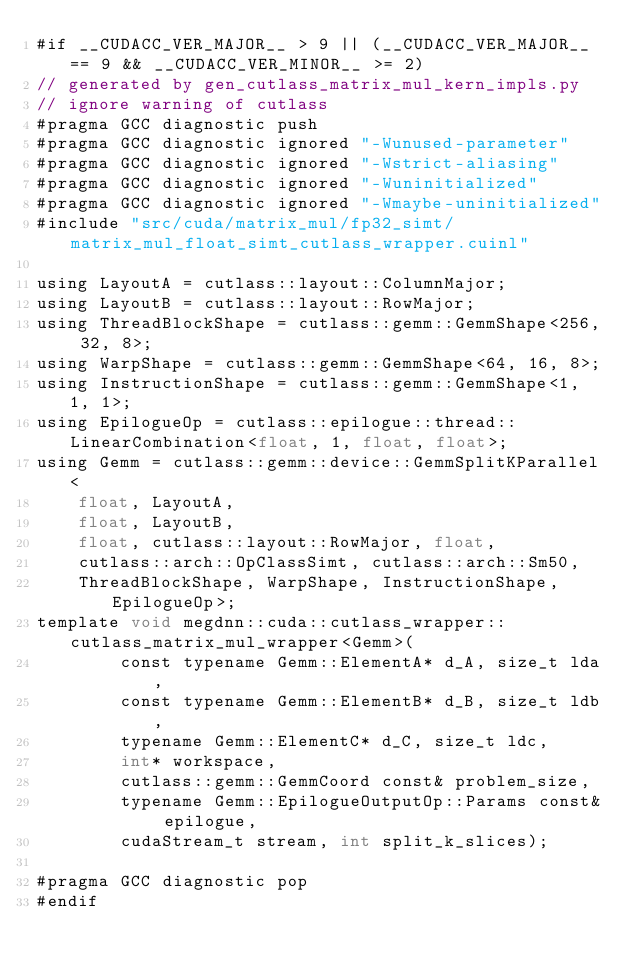<code> <loc_0><loc_0><loc_500><loc_500><_Cuda_>#if __CUDACC_VER_MAJOR__ > 9 || (__CUDACC_VER_MAJOR__ == 9 && __CUDACC_VER_MINOR__ >= 2)
// generated by gen_cutlass_matrix_mul_kern_impls.py
// ignore warning of cutlass
#pragma GCC diagnostic push
#pragma GCC diagnostic ignored "-Wunused-parameter"
#pragma GCC diagnostic ignored "-Wstrict-aliasing"
#pragma GCC diagnostic ignored "-Wuninitialized"
#pragma GCC diagnostic ignored "-Wmaybe-uninitialized"
#include "src/cuda/matrix_mul/fp32_simt/matrix_mul_float_simt_cutlass_wrapper.cuinl"

using LayoutA = cutlass::layout::ColumnMajor;
using LayoutB = cutlass::layout::RowMajor;
using ThreadBlockShape = cutlass::gemm::GemmShape<256, 32, 8>;
using WarpShape = cutlass::gemm::GemmShape<64, 16, 8>;
using InstructionShape = cutlass::gemm::GemmShape<1, 1, 1>;
using EpilogueOp = cutlass::epilogue::thread::LinearCombination<float, 1, float, float>;
using Gemm = cutlass::gemm::device::GemmSplitKParallel<
    float, LayoutA, 
    float, LayoutB, 
    float, cutlass::layout::RowMajor, float, 
    cutlass::arch::OpClassSimt, cutlass::arch::Sm50, 
    ThreadBlockShape, WarpShape, InstructionShape, EpilogueOp>;
template void megdnn::cuda::cutlass_wrapper::cutlass_matrix_mul_wrapper<Gemm>(
        const typename Gemm::ElementA* d_A, size_t lda, 
        const typename Gemm::ElementB* d_B, size_t ldb,  
        typename Gemm::ElementC* d_C, size_t ldc,  
        int* workspace, 
        cutlass::gemm::GemmCoord const& problem_size,   
        typename Gemm::EpilogueOutputOp::Params const& epilogue, 
        cudaStream_t stream, int split_k_slices);

#pragma GCC diagnostic pop
#endif
</code> 